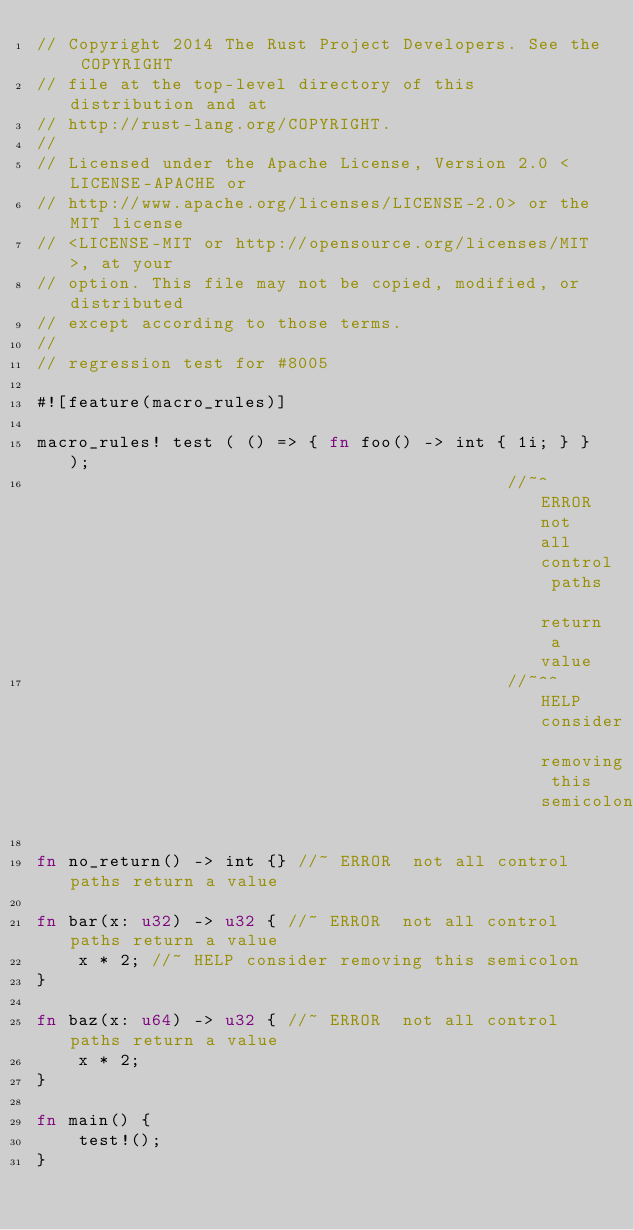<code> <loc_0><loc_0><loc_500><loc_500><_Rust_>// Copyright 2014 The Rust Project Developers. See the COPYRIGHT
// file at the top-level directory of this distribution and at
// http://rust-lang.org/COPYRIGHT.
//
// Licensed under the Apache License, Version 2.0 <LICENSE-APACHE or
// http://www.apache.org/licenses/LICENSE-2.0> or the MIT license
// <LICENSE-MIT or http://opensource.org/licenses/MIT>, at your
// option. This file may not be copied, modified, or distributed
// except according to those terms.
//
// regression test for #8005

#![feature(macro_rules)]

macro_rules! test ( () => { fn foo() -> int { 1i; } } );
                                             //~^ ERROR not all control paths return a value
                                             //~^^ HELP consider removing this semicolon

fn no_return() -> int {} //~ ERROR  not all control paths return a value

fn bar(x: u32) -> u32 { //~ ERROR  not all control paths return a value
    x * 2; //~ HELP consider removing this semicolon
}

fn baz(x: u64) -> u32 { //~ ERROR  not all control paths return a value
    x * 2;
}

fn main() {
    test!();
}
</code> 